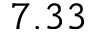<formula> <loc_0><loc_0><loc_500><loc_500>7 . 3 3</formula> 